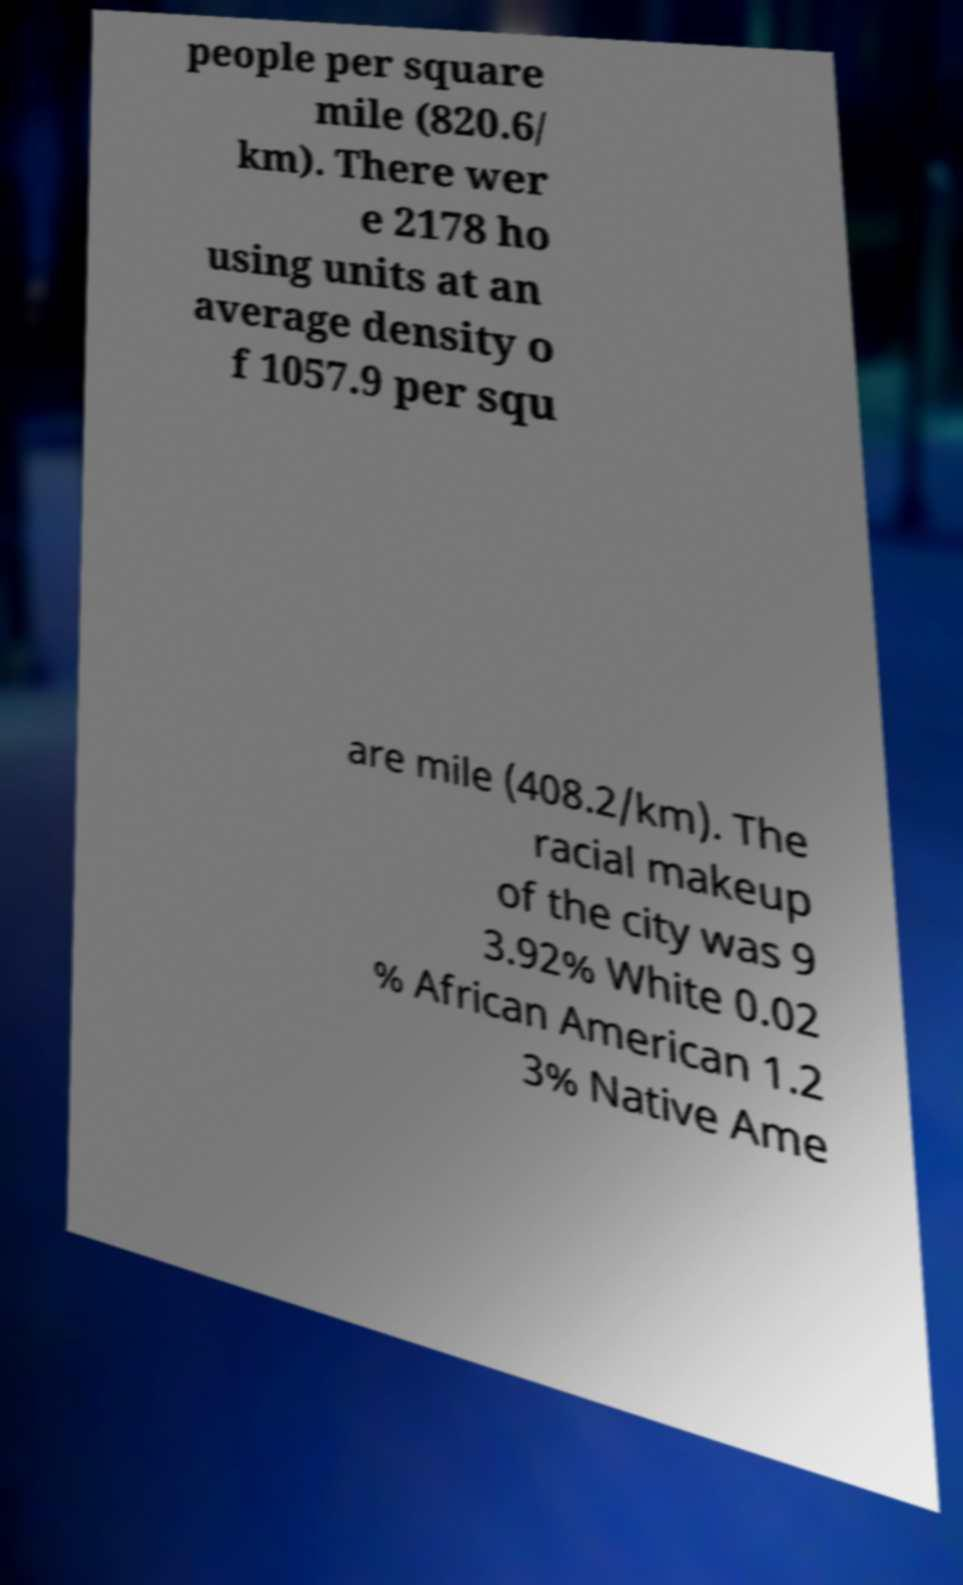There's text embedded in this image that I need extracted. Can you transcribe it verbatim? people per square mile (820.6/ km). There wer e 2178 ho using units at an average density o f 1057.9 per squ are mile (408.2/km). The racial makeup of the city was 9 3.92% White 0.02 % African American 1.2 3% Native Ame 